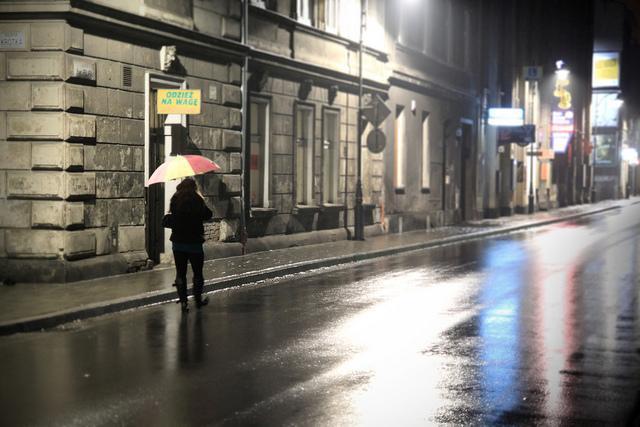How many people are in the photo?
Give a very brief answer. 1. How many people are there?
Give a very brief answer. 1. How many planes have orange tail sections?
Give a very brief answer. 0. 